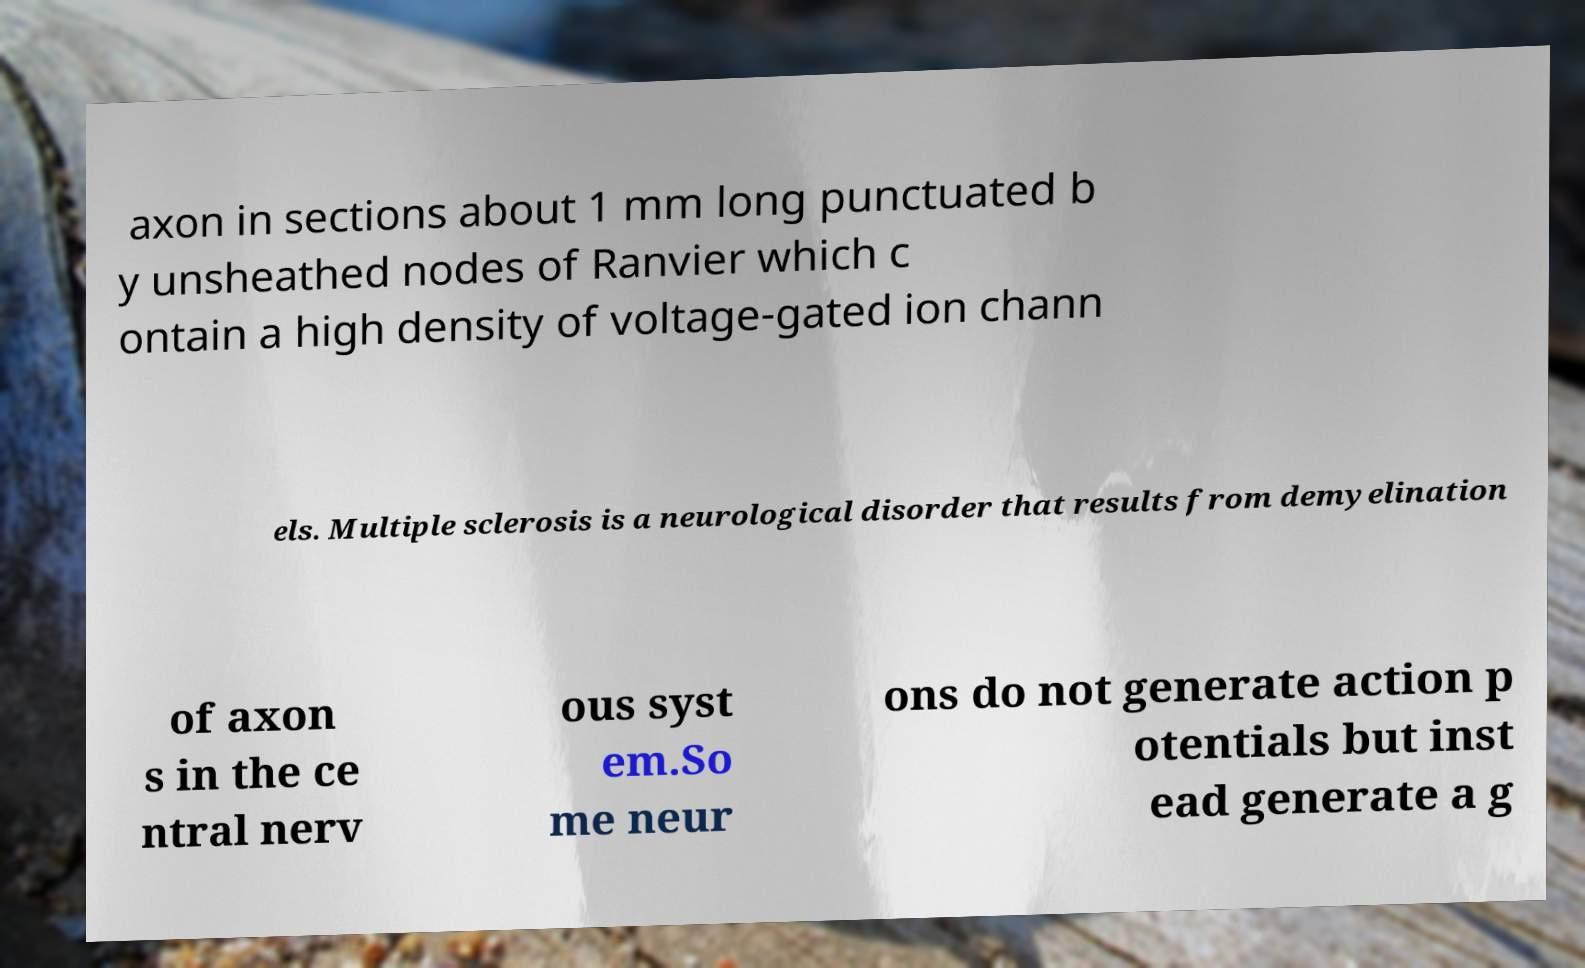For documentation purposes, I need the text within this image transcribed. Could you provide that? axon in sections about 1 mm long punctuated b y unsheathed nodes of Ranvier which c ontain a high density of voltage-gated ion chann els. Multiple sclerosis is a neurological disorder that results from demyelination of axon s in the ce ntral nerv ous syst em.So me neur ons do not generate action p otentials but inst ead generate a g 